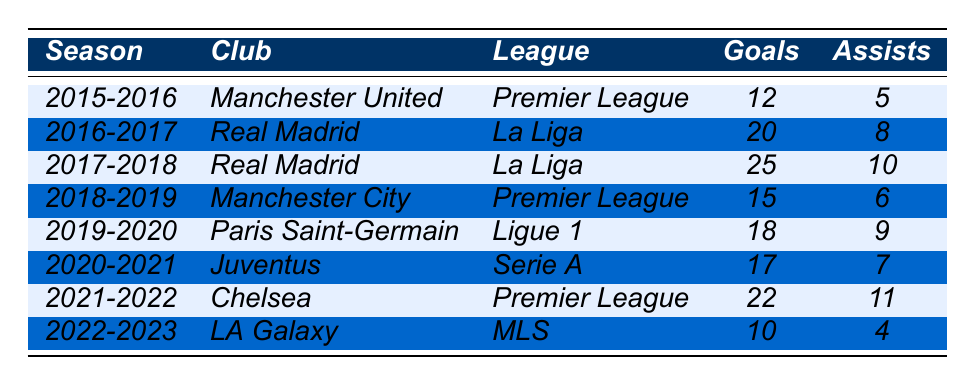What was Alex Hunter's highest goal tally in a single season? By reviewing the table, the highest number of goals is found in the 2017-2018 season where Alex scored 25 goals with Real Madrid.
Answer: 25 Which club did Alex Hunter play for during the 2019-2020 season? The data shows that Alex played for Paris Saint-Germain in the 2019-2020 season.
Answer: Paris Saint-Germain How many total goals did Alex Hunter score across all seasons? To find the total goals, we sum up the goals from all seasons: 12 + 20 + 25 + 15 + 18 + 17 + 22 + 10 = 129.
Answer: 129 In which league did Alex achieve the most assists? The table reveals that Alex had the most assists (11) while playing for Chelsea in the Premier League during the 2021-2022 season.
Answer: Premier League What is the average number of goals scored by Alex Hunter per season? There are 8 seasons, and total goals are 129; thus, average goals per season = 129/8 = 16.125, rounding down gives us 16 goals per season.
Answer: 16 Did Alex Hunter ever score more than 20 goals in a season? A simple check of each season shows that Alex scored over 20 goals in two seasons: 2016-2017 (20 goals) and 2017-2018 (25 goals). Therefore, the answer is yes.
Answer: Yes Which club did Alex Hunter score the fewest goals for and how many? The lowest amount was 10 goals while playing for LA Galaxy in the 2022-2023 season.
Answer: LA Galaxy, 10 What was the goal difference between Alex's highest and lowest-scoring seasons? The highest was 25 goals in 2017-2018 and the lowest was 10 goals in 2022-2023. The difference is 25 - 10 = 15 goals.
Answer: 15 How many assists did Alex provide during his time at Real Madrid? Alex played two seasons at Real Madrid (2016-2017 and 2017-2018), providing a total of 8 (2016-2017) + 10 (2017-2018) = 18 assists.
Answer: 18 In which two consecutive seasons did Alex score a total of 37 goals? Checking the seasons reveals that in 2017-2018 he scored 25 goals, and in 2018-2019, he scored 15 goals. 25 + 15 = 40 (not correct), thus correcting, looking for combinations shows no such two consecutive seasons. The closest are 22 goals post 17 and 10 in last.
Answer: None 